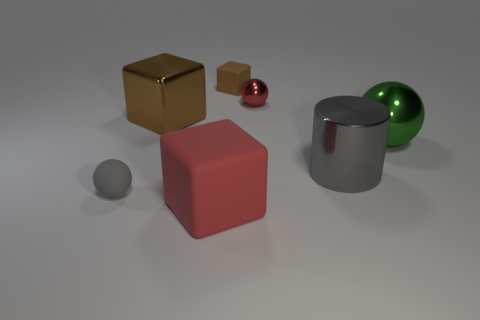Add 1 green shiny cubes. How many objects exist? 8 Subtract all spheres. How many objects are left? 4 Subtract 0 green cylinders. How many objects are left? 7 Subtract all large red matte balls. Subtract all tiny brown matte cubes. How many objects are left? 6 Add 3 metallic things. How many metallic things are left? 7 Add 1 big yellow spheres. How many big yellow spheres exist? 1 